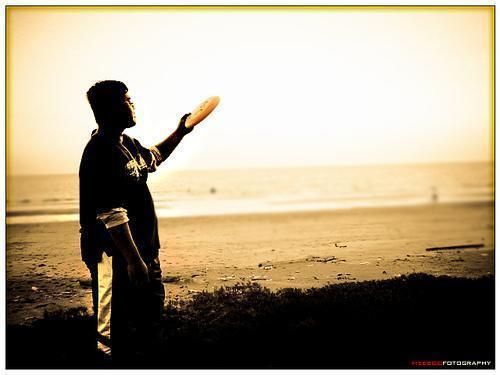How many stripes of the tie are below the mans right hand?
Give a very brief answer. 0. 